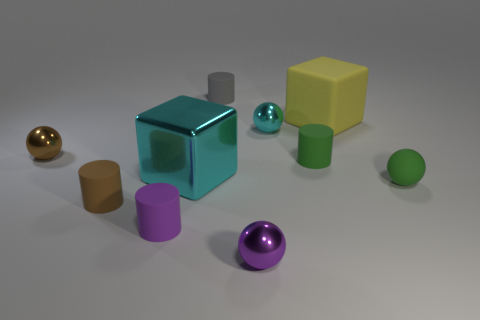Subtract 2 spheres. How many spheres are left? 2 Subtract all red cylinders. Subtract all cyan spheres. How many cylinders are left? 4 Subtract all cubes. How many objects are left? 8 Subtract all big purple metal things. Subtract all tiny balls. How many objects are left? 6 Add 3 small green rubber balls. How many small green rubber balls are left? 4 Add 3 purple balls. How many purple balls exist? 4 Subtract 0 green blocks. How many objects are left? 10 